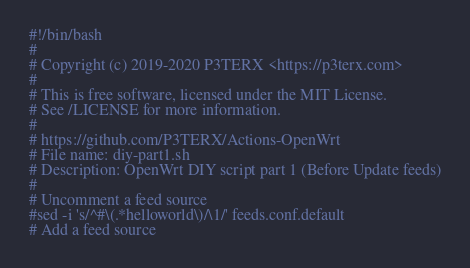<code> <loc_0><loc_0><loc_500><loc_500><_Bash_>#!/bin/bash
#
# Copyright (c) 2019-2020 P3TERX <https://p3terx.com>
#
# This is free software, licensed under the MIT License.
# See /LICENSE for more information.
#
# https://github.com/P3TERX/Actions-OpenWrt
# File name: diy-part1.sh
# Description: OpenWrt DIY script part 1 (Before Update feeds)
#
# Uncomment a feed source
#sed -i 's/^#\(.*helloworld\)/\1/' feeds.conf.default
# Add a feed source</code> 